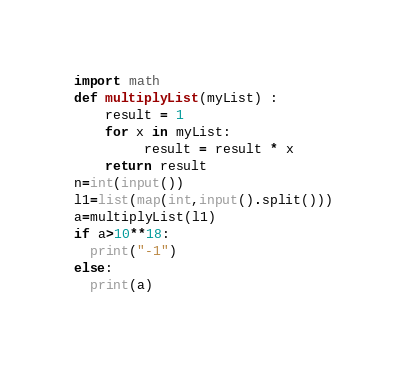Convert code to text. <code><loc_0><loc_0><loc_500><loc_500><_Python_>import math
def multiplyList(myList) : 
    result = 1
    for x in myList: 
         result = result * x  
    return result 
n=int(input())
l1=list(map(int,input().split()))
a=multiplyList(l1)
if a>10**18:
  print("-1")
else:
  print(a)</code> 